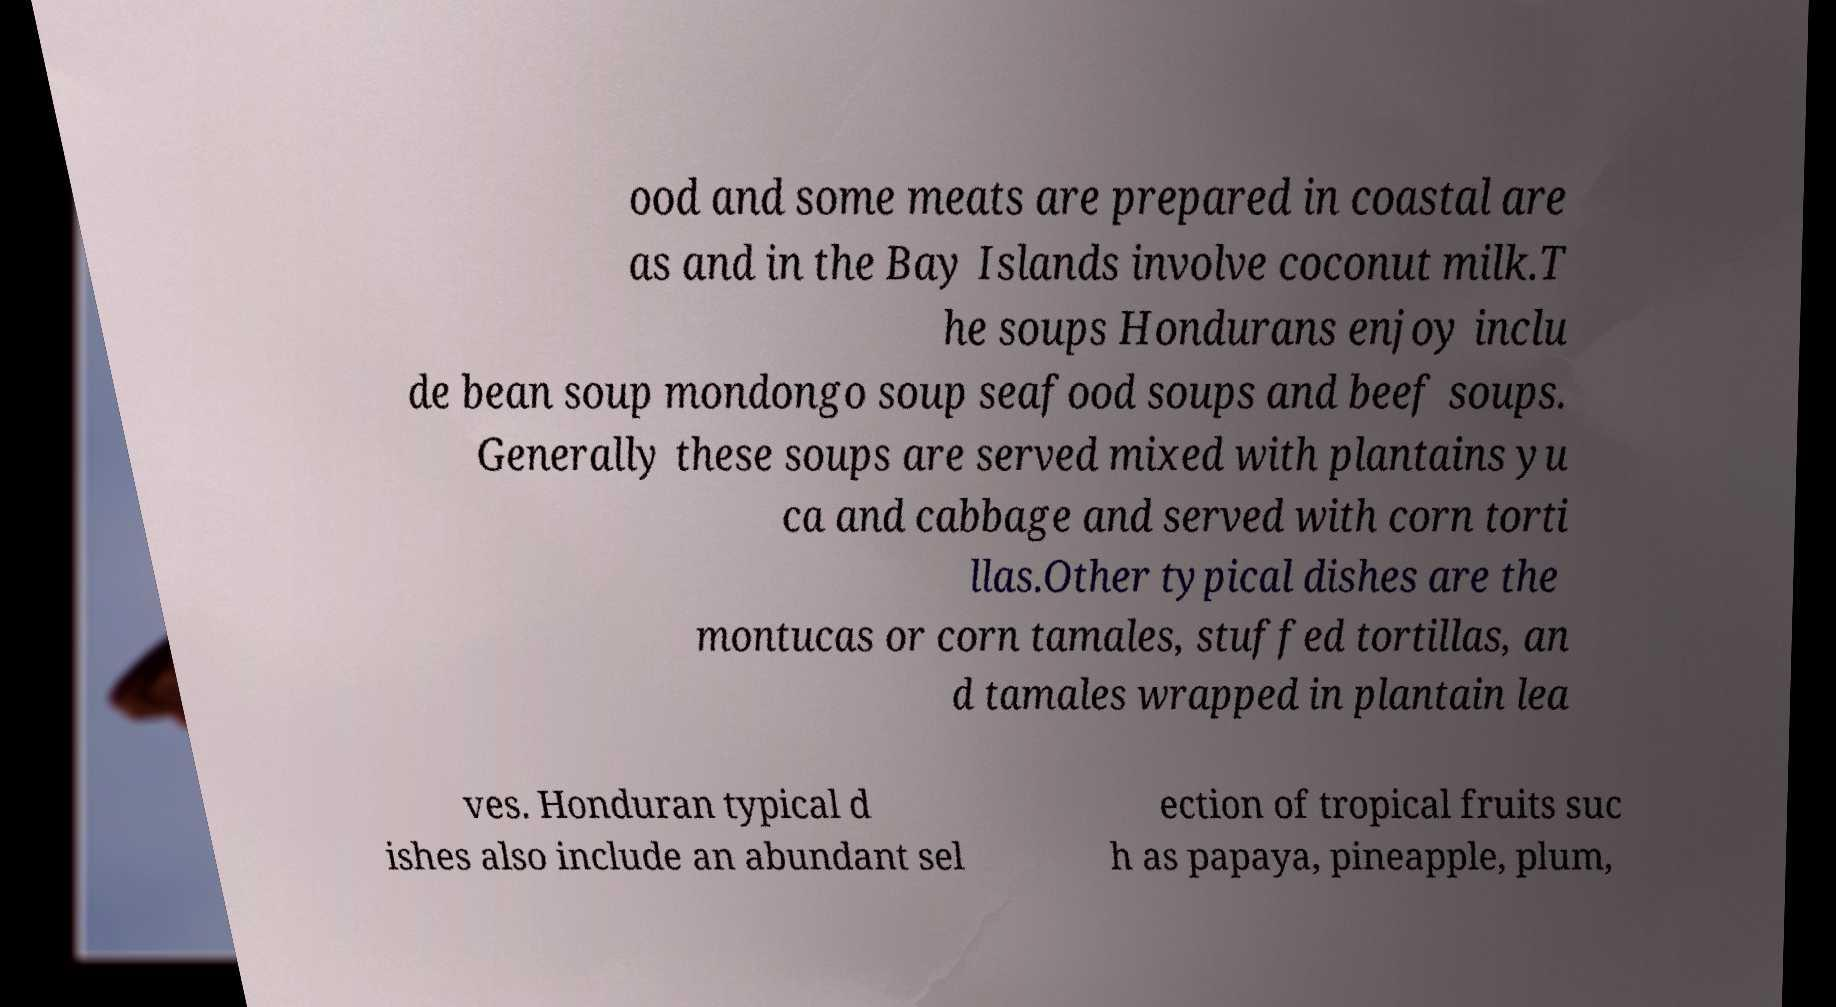Can you accurately transcribe the text from the provided image for me? ood and some meats are prepared in coastal are as and in the Bay Islands involve coconut milk.T he soups Hondurans enjoy inclu de bean soup mondongo soup seafood soups and beef soups. Generally these soups are served mixed with plantains yu ca and cabbage and served with corn torti llas.Other typical dishes are the montucas or corn tamales, stuffed tortillas, an d tamales wrapped in plantain lea ves. Honduran typical d ishes also include an abundant sel ection of tropical fruits suc h as papaya, pineapple, plum, 